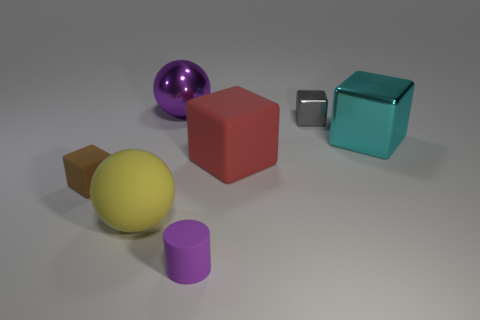There is a big shiny thing that is left of the large block that is on the right side of the small gray shiny object; what is its shape?
Make the answer very short. Sphere. What shape is the big metallic object that is behind the shiny block that is in front of the tiny cube to the right of the small brown thing?
Your response must be concise. Sphere. How many purple objects are the same shape as the large yellow object?
Ensure brevity in your answer.  1. There is a tiny thing that is behind the large cyan shiny object; what number of tiny metal things are to the left of it?
Your answer should be very brief. 0. How many shiny things are tiny gray cylinders or tiny brown cubes?
Give a very brief answer. 0. Is there a big yellow thing made of the same material as the small purple object?
Give a very brief answer. Yes. How many things are blocks that are behind the brown block or large rubber objects on the right side of the purple rubber object?
Make the answer very short. 3. Do the small rubber thing that is behind the large yellow ball and the matte cylinder have the same color?
Keep it short and to the point. No. What number of other objects are the same color as the metallic sphere?
Provide a succinct answer. 1. What material is the large purple ball?
Give a very brief answer. Metal. 